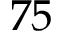<formula> <loc_0><loc_0><loc_500><loc_500>7 5</formula> 